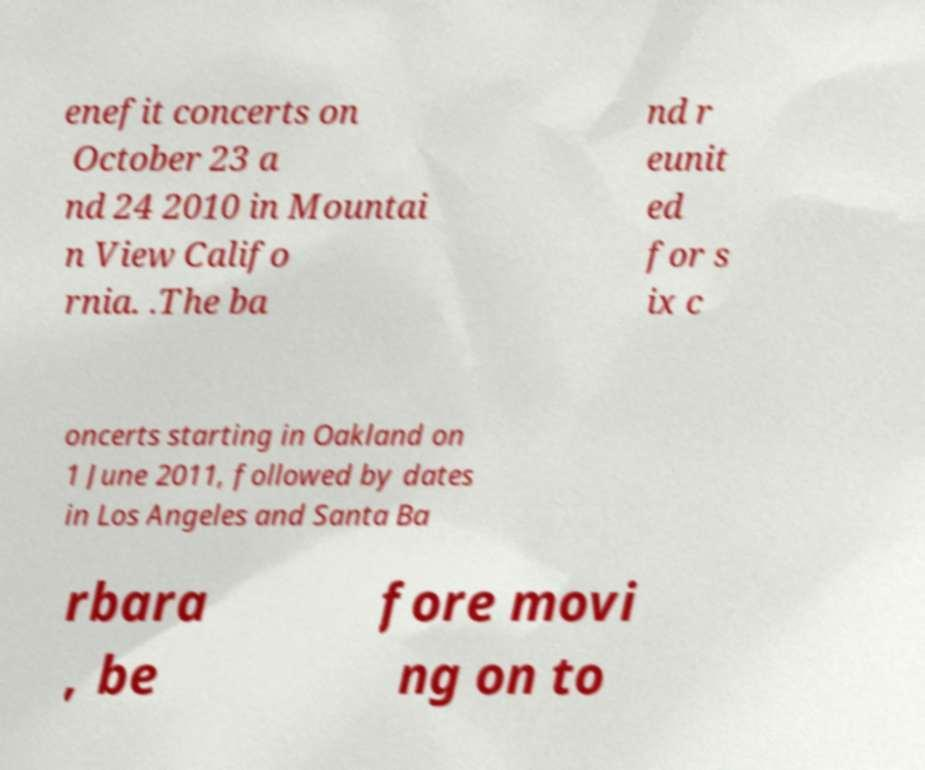There's text embedded in this image that I need extracted. Can you transcribe it verbatim? enefit concerts on October 23 a nd 24 2010 in Mountai n View Califo rnia. .The ba nd r eunit ed for s ix c oncerts starting in Oakland on 1 June 2011, followed by dates in Los Angeles and Santa Ba rbara , be fore movi ng on to 